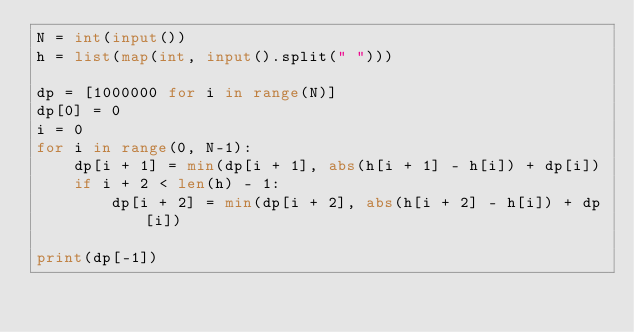Convert code to text. <code><loc_0><loc_0><loc_500><loc_500><_Python_>N = int(input())
h = list(map(int, input().split(" ")))

dp = [1000000 for i in range(N)]
dp[0] = 0
i = 0
for i in range(0, N-1):
    dp[i + 1] = min(dp[i + 1], abs(h[i + 1] - h[i]) + dp[i])
    if i + 2 < len(h) - 1:
        dp[i + 2] = min(dp[i + 2], abs(h[i + 2] - h[i]) + dp[i])

print(dp[-1])</code> 